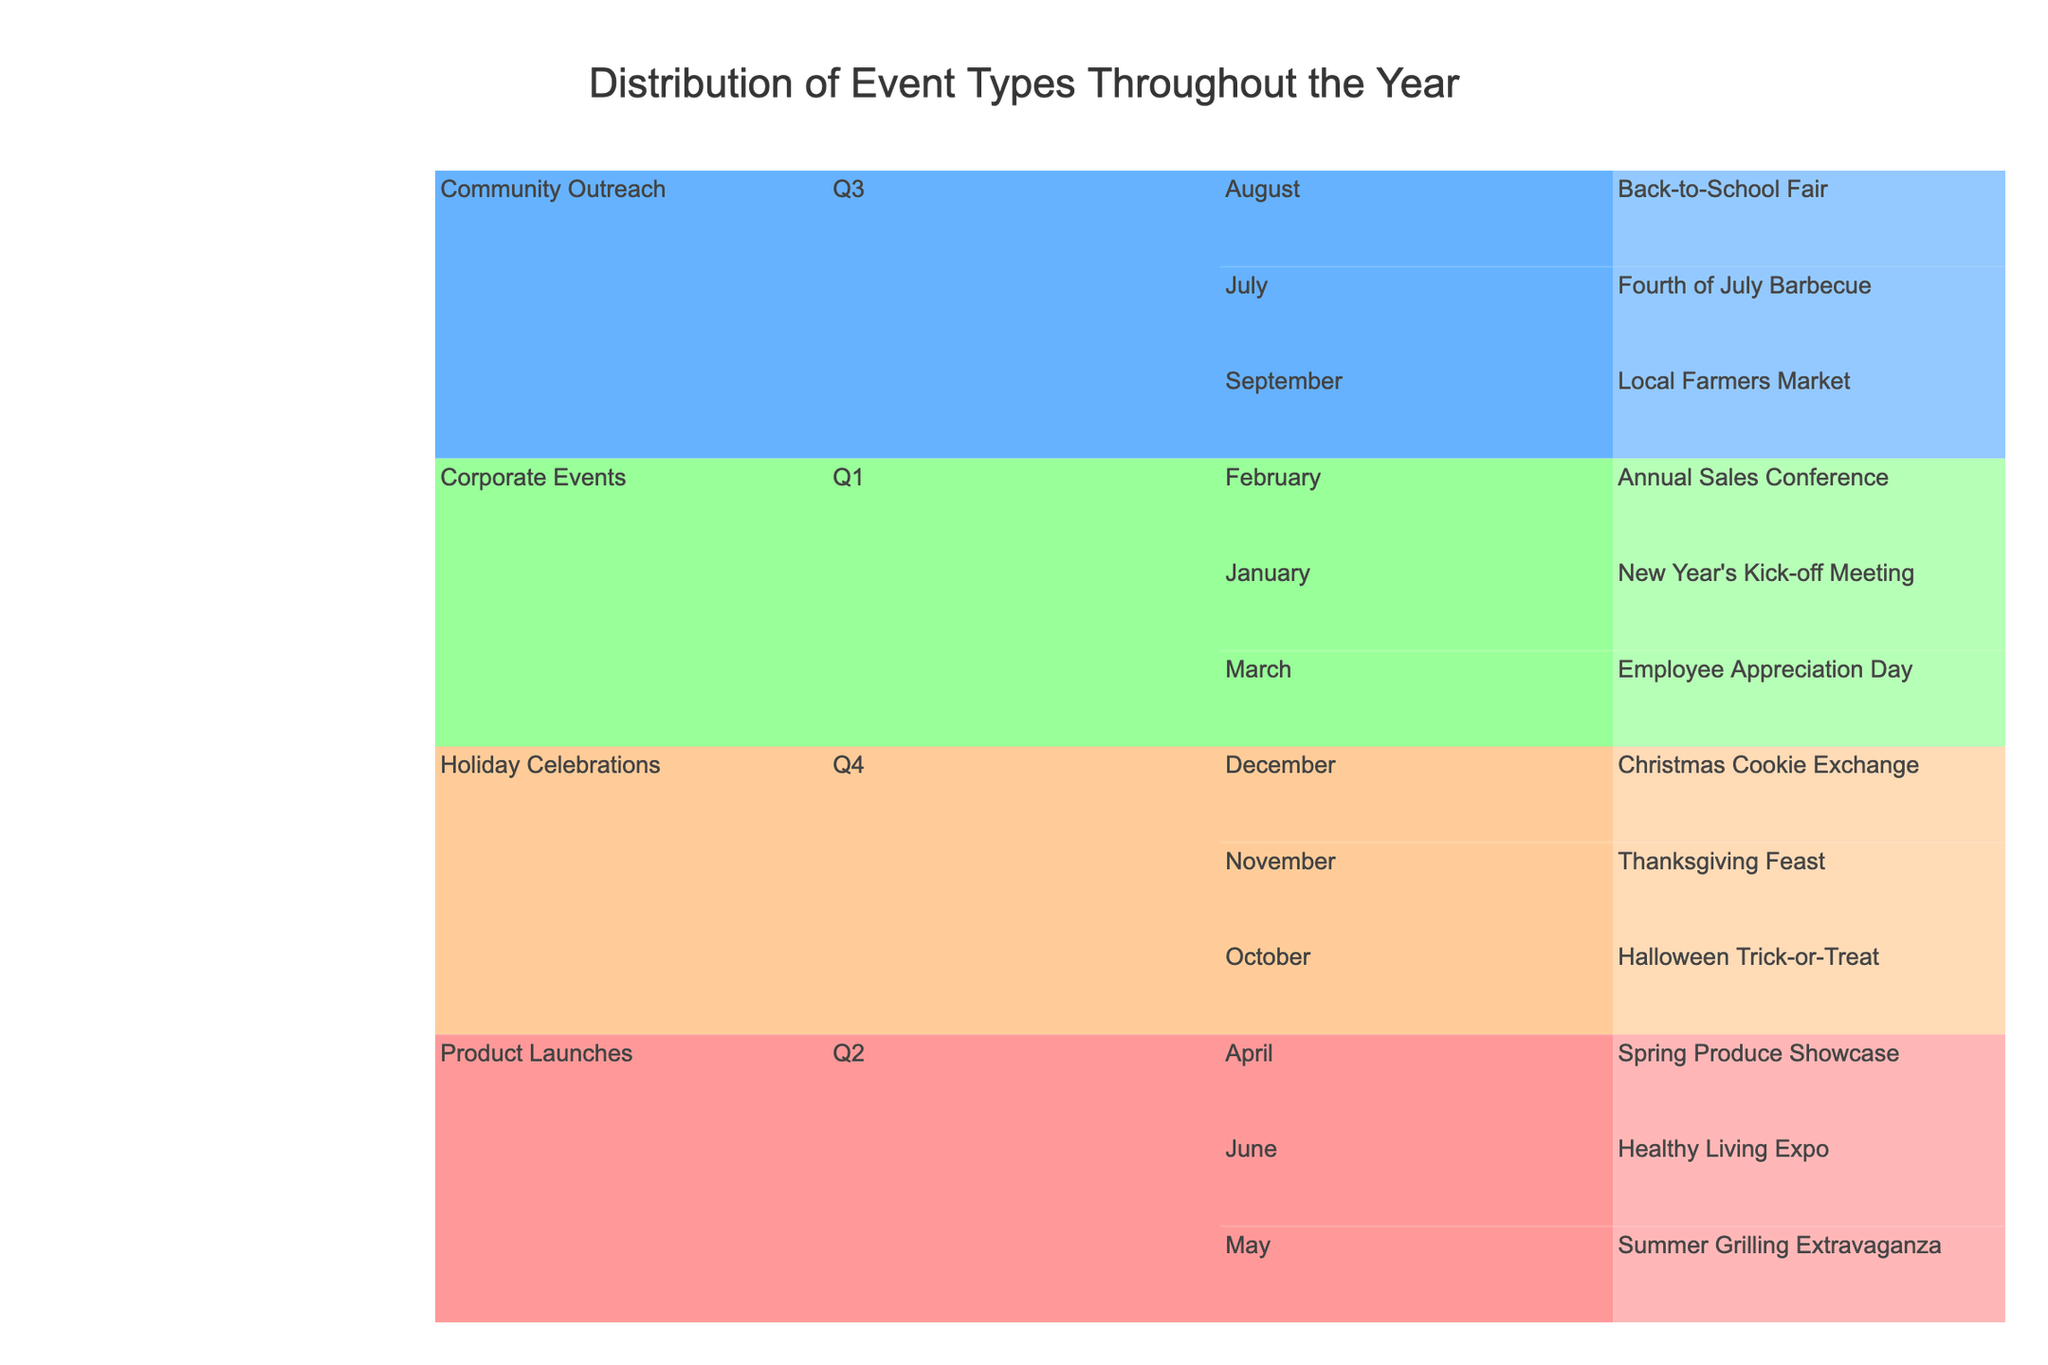What is the title of the Icicle Chart? The title is placed at the top of the chart, indicating the subject of the visualization. You can find it by looking at the center-top part of the figure.
Answer: Distribution of Event Types Throughout the Year How many quarters are represented in the chart? The chart is designed to show different quarters of the year. By examining the chart, you can count how many unique quarters (Q1, Q2, Q3, Q4) are mentioned.
Answer: 4 Which event type has the most specific events listed in Q2? To determine this, look for the Q2 section and then observe how many specific events are listed under each event type.
Answer: Product Launches How many events are organized in the first half of the year? The first half of the year covers Q1 and Q2. Count the events listed under Q1 and Q2 to get the total. Q1 has 3 events and Q2 has 3 events.
Answer: 6 Which month has the fewest events organized? To answer this, look at the breakdown of months under each quarter and count the events per month. Identify the month with the lowest count.
Answer: April In which quarter is the "Thanksgiving Feast" event? Locate "Thanksgiving Feast" in the chart and follow its path back to identify the corresponding quarter.
Answer: Q4 Are there more holiday celebrations or product launches throughout the year? Compare the number of events listed under "Holiday Celebrations" and "Product Launches" to determine which category has more events.
Answer: Holiday Celebrations Which specific events occur in Q3? To find this, examine the entire Q3 section and list the specific events under it.
Answer: Fourth of July Barbecue, Back-to-School Fair, Local Farmers Market How does the number of community outreach events compare between Q3 and Q1? Count the community outreach events in Q3 and Q1, then compare the two counts. Q3 has 3 events, while Q1 has 0 community outreach events.
Answer: Q3 has more community outreach events What is the most frequent type of event throughout the year? Look at the distribution of events under each event type across all quarters and months, then identify which type has the most events.
Answer: Holiday Celebrations 